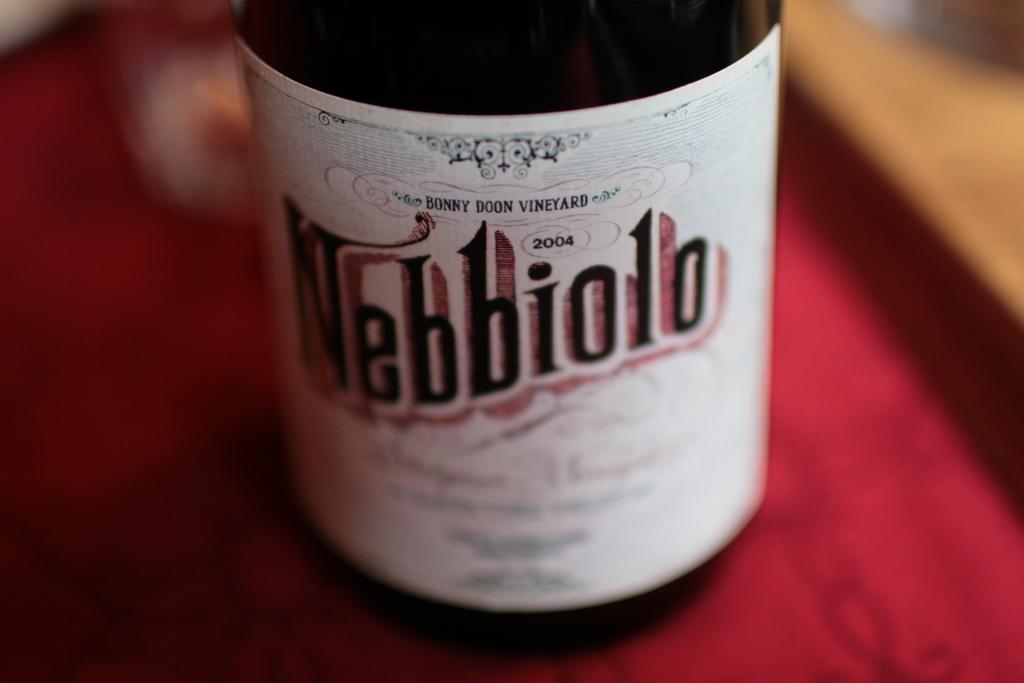What kind of drink is this?
Your response must be concise. Nebbiolo. 